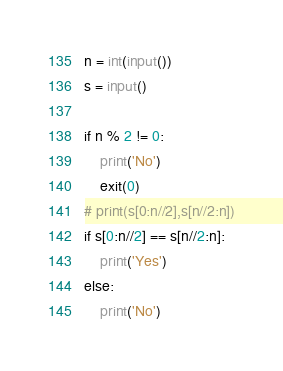Convert code to text. <code><loc_0><loc_0><loc_500><loc_500><_Python_>n = int(input())
s = input()

if n % 2 != 0:
    print('No')
    exit(0)
# print(s[0:n//2],s[n//2:n])
if s[0:n//2] == s[n//2:n]:
    print('Yes')
else:
    print('No')
</code> 